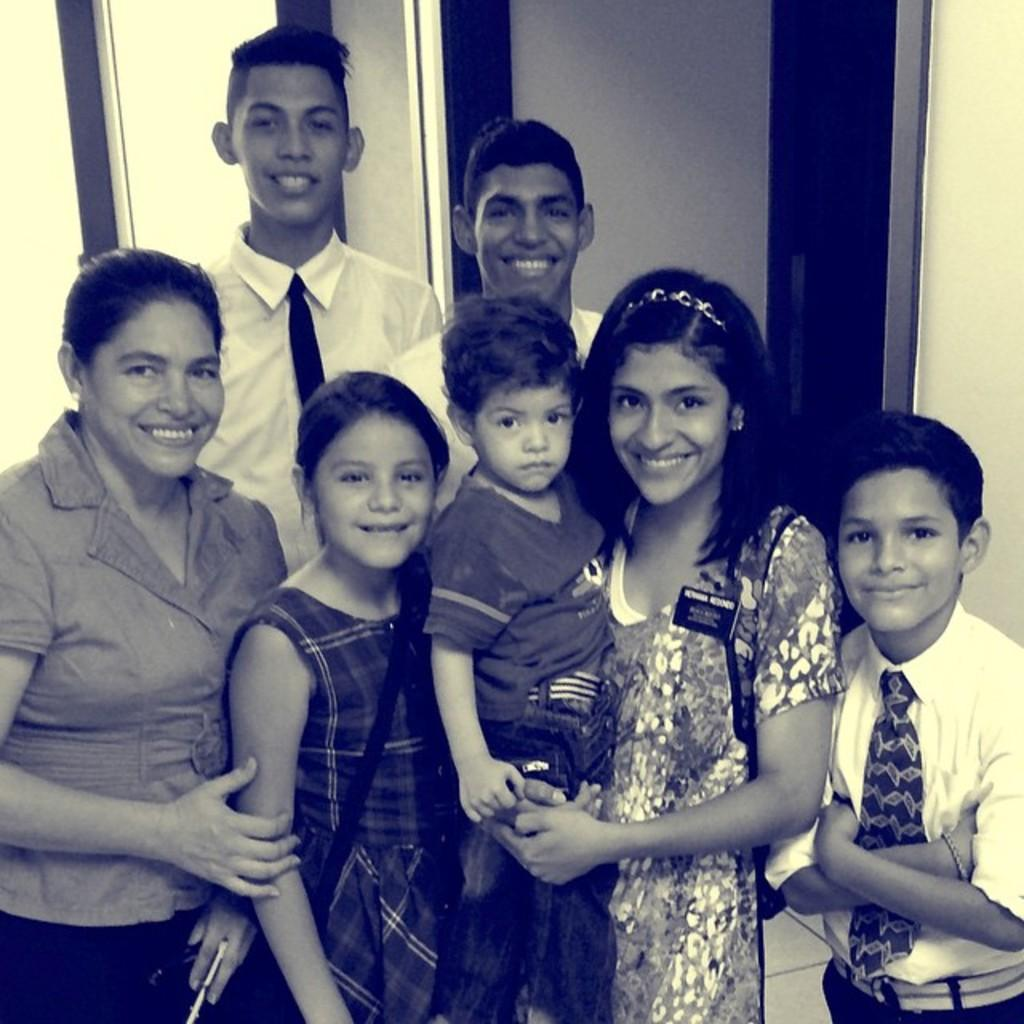How many people are in the image? There are people in the image, but the exact number is not specified. What is the general expression of the people in the image? Most of the people have smiles on their faces. What type of spade is being used to rate the shop in the image? There is no spade or shop present in the image. 